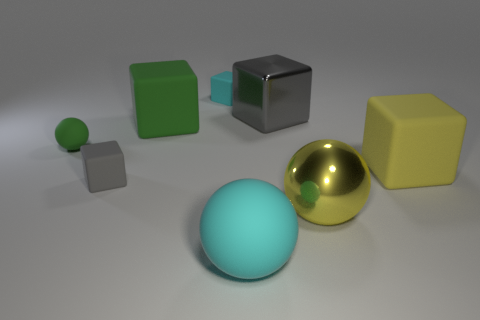Add 1 tiny shiny things. How many objects exist? 9 Subtract all tiny gray cubes. How many cubes are left? 4 Subtract all blue balls. How many gray cubes are left? 2 Subtract 3 balls. How many balls are left? 0 Subtract all balls. How many objects are left? 5 Subtract all yellow cubes. How many cubes are left? 4 Subtract 1 cyan balls. How many objects are left? 7 Subtract all red blocks. Subtract all blue cylinders. How many blocks are left? 5 Subtract all metal balls. Subtract all cyan things. How many objects are left? 5 Add 1 large yellow rubber things. How many large yellow rubber things are left? 2 